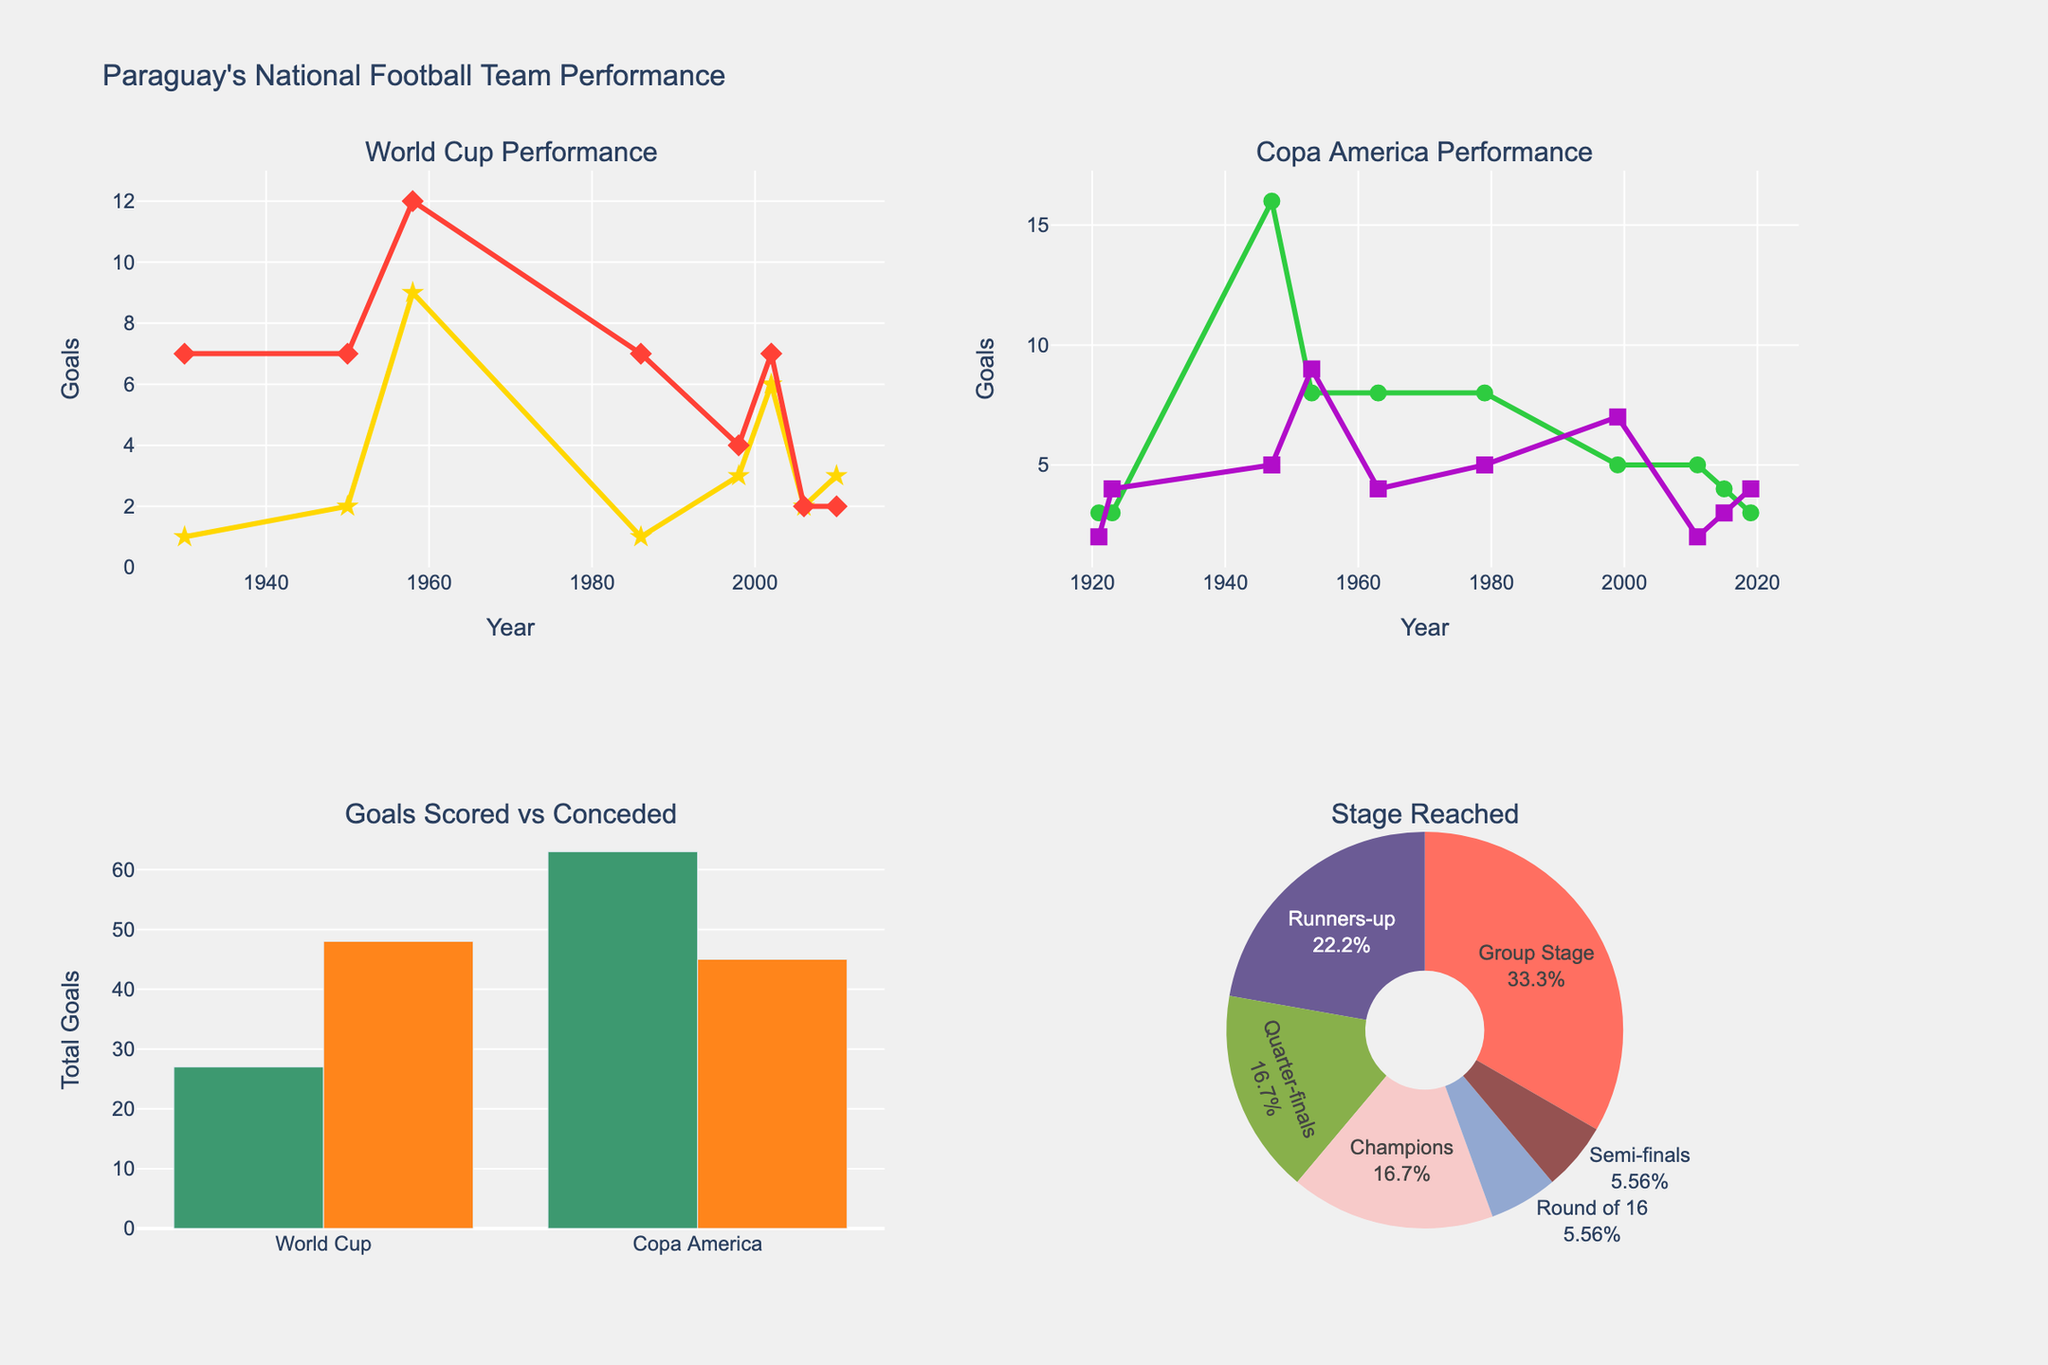What is the title of the figure? The title of the figure is located at the top center of the plot. It reads, "Paraguay's National Football Team Performance." This is confirmed by observing the text at the top center of the image.
Answer: Paraguay's National Football Team Performance In which years did Paraguay's national football team score more goals in the World Cup? Look at the "World Cup Performance" subplot and observe the 'Goals Scored' line. The years with the highest peaks correspond to the years Paraguay scored the most goals. Notice the highest points are in 1958 and 2002.
Answer: 1958, 2002 How many goals were scored by Paraguay in Copa America when the most goals were conceded? Check the "Copa America Performance" subplot and identify the peak years for 'Goals Conceded.' In 1947, Paraguay conceded the most goals (5). The corresponding 'Goals Scored' value in 1947 is 16.
Answer: 16 How does the total number of goals scored compare between World Cup and Copa America? Refer to the "Goals Scored vs Conceded" bar chart. Compare the height of the bars for 'Goals Scored' in World Cup and Copa America. The Copa America bar is taller, indicating more goals scored in Copa America overall.
Answer: More in Copa America Which stage was reached most frequently by Paraguay's national football team in international tournaments? Observe the "Stage Reached" pie chart and identify the section with the largest proportion. The largest segment corresponds to the 'Group Stage'.
Answer: Group Stage How many goals did Paraguay concede in the year 2011 Copa America? Look at the "Copa America Performance" subplot and find the year 2011. The 'Goals Conceded' value for 2011 is 2.
Answer: 2 What trend can be observed in the "World Cup Performance" subplot regarding goals scored over the years? Notice the peaks and troughs in the 'Goals Scored' line in the "World Cup Performance" subplot. The goals scored fluctuate with no consistent increase or decrease, indicating a variable performance across years.
Answer: Variable performance Which tournament saw Paraguay conceding more goals on average, World Cup or Copa America? Sum up the goals conceded in both tournaments and divide by the number of participations in each. In the World Cup, the average is calculated ( (7+7+12+7+4+7+2+2)/8). In Copa America, the average is ( (2+4+5+9+4+5+7+2+3+4)/10). Average comparison suggests World Cup has higher average goals conceded.
Answer: World Cup What year did Paraguay reach the finals in Copa America but did not win, and how many goals were scored? Look at the "Copa America Performance" subplot. Identify the year and corresponding stages in "Stage Reached". The years they were runners-up without winning are 1953 and 2011. The 'Goals Scored' values are 8 and 5 for those years, respectively.
Answer: 1953: 8, 2011: 5 